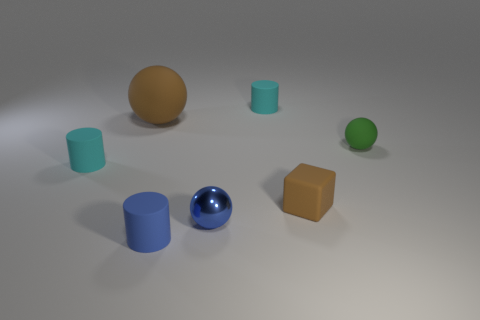Is there anything else that has the same material as the small blue ball?
Keep it short and to the point. No. How many rubber objects are either small green balls or large spheres?
Ensure brevity in your answer.  2. Are there an equal number of cyan rubber things behind the large rubber ball and small green matte balls?
Your response must be concise. Yes. There is a rubber cylinder left of the big brown rubber thing; does it have the same color as the metal ball?
Provide a short and direct response. No. The cylinder that is in front of the green ball and behind the blue matte object is made of what material?
Keep it short and to the point. Rubber. Is there a tiny cyan rubber thing that is on the right side of the small cylinder on the right side of the metal thing?
Offer a terse response. No. Does the small block have the same material as the tiny blue sphere?
Your answer should be very brief. No. What is the shape of the small thing that is both on the left side of the blue metal object and in front of the tiny matte block?
Your answer should be compact. Cylinder. There is a cyan thing that is behind the small cyan matte object on the left side of the large rubber ball; what size is it?
Offer a terse response. Small. How many tiny green matte objects have the same shape as the blue metallic thing?
Provide a succinct answer. 1. 